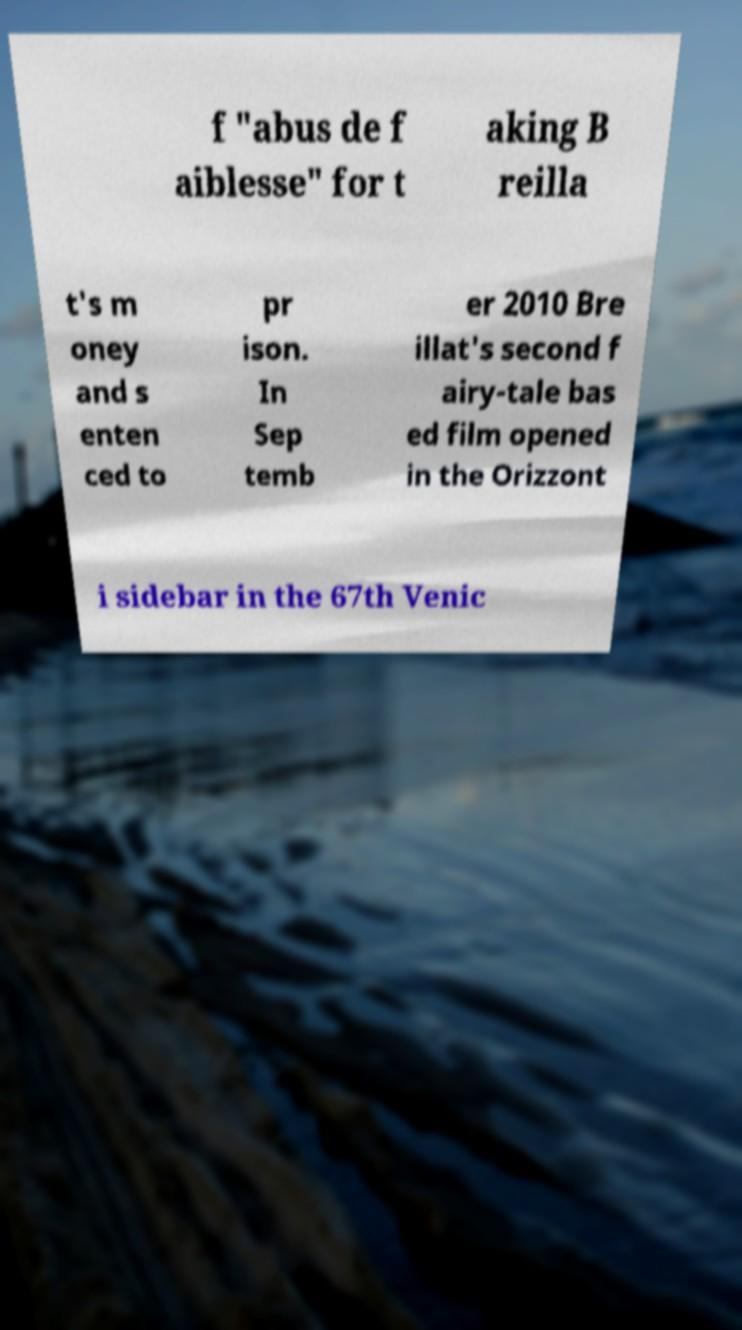Can you read and provide the text displayed in the image?This photo seems to have some interesting text. Can you extract and type it out for me? f "abus de f aiblesse" for t aking B reilla t's m oney and s enten ced to pr ison. In Sep temb er 2010 Bre illat's second f airy-tale bas ed film opened in the Orizzont i sidebar in the 67th Venic 